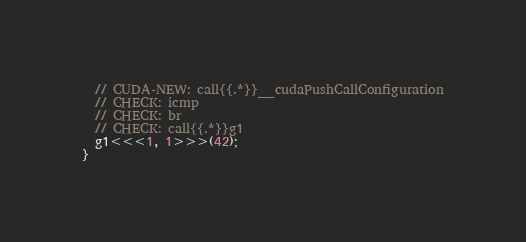Convert code to text. <code><loc_0><loc_0><loc_500><loc_500><_Cuda_>  // CUDA-NEW: call{{.*}}__cudaPushCallConfiguration
  // CHECK: icmp
  // CHECK: br
  // CHECK: call{{.*}}g1
  g1<<<1, 1>>>(42);
}
</code> 